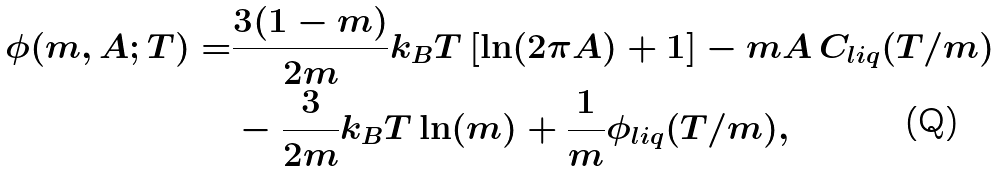Convert formula to latex. <formula><loc_0><loc_0><loc_500><loc_500>\phi ( m , A ; T ) = & \frac { 3 ( 1 - m ) } { 2 m } k _ { B } T \left [ \ln ( 2 \pi A ) + 1 \right ] - m A \, C _ { l i q } ( T / m ) \\ & - \frac { 3 } { 2 m } k _ { B } T \ln ( m ) + \frac { 1 } { m } \phi _ { l i q } ( T / m ) ,</formula> 